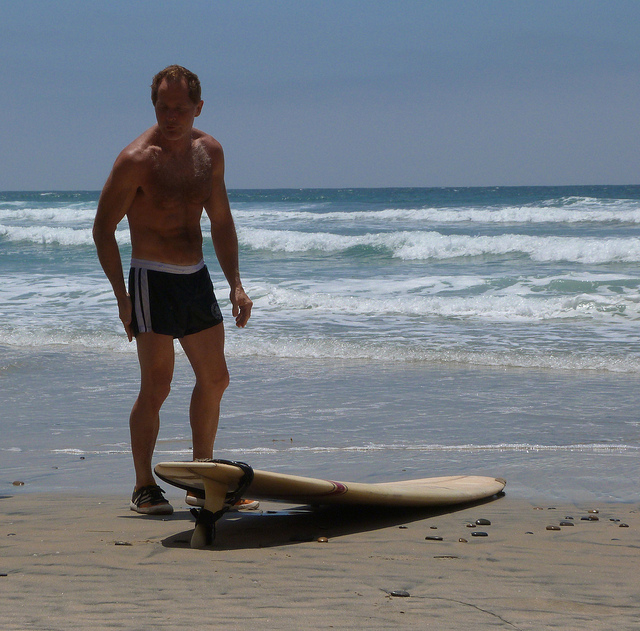Can you provide some background information about why surfers use straps with their surfboards? Certainly! Surfers often utilize leg ropes or leashes, which are straps attached to the tail end of the surfboard and wrapped around the surfer's ankle. The primary purpose of the leash is to prevent the surfboard from being swept away by waves in case the surfer falls off, ensuring the board remains close and can be retrieved quickly. This safety measure also helps avoid accidents, as a runaway surfboard can pose a danger to other surfers and swimmers. 